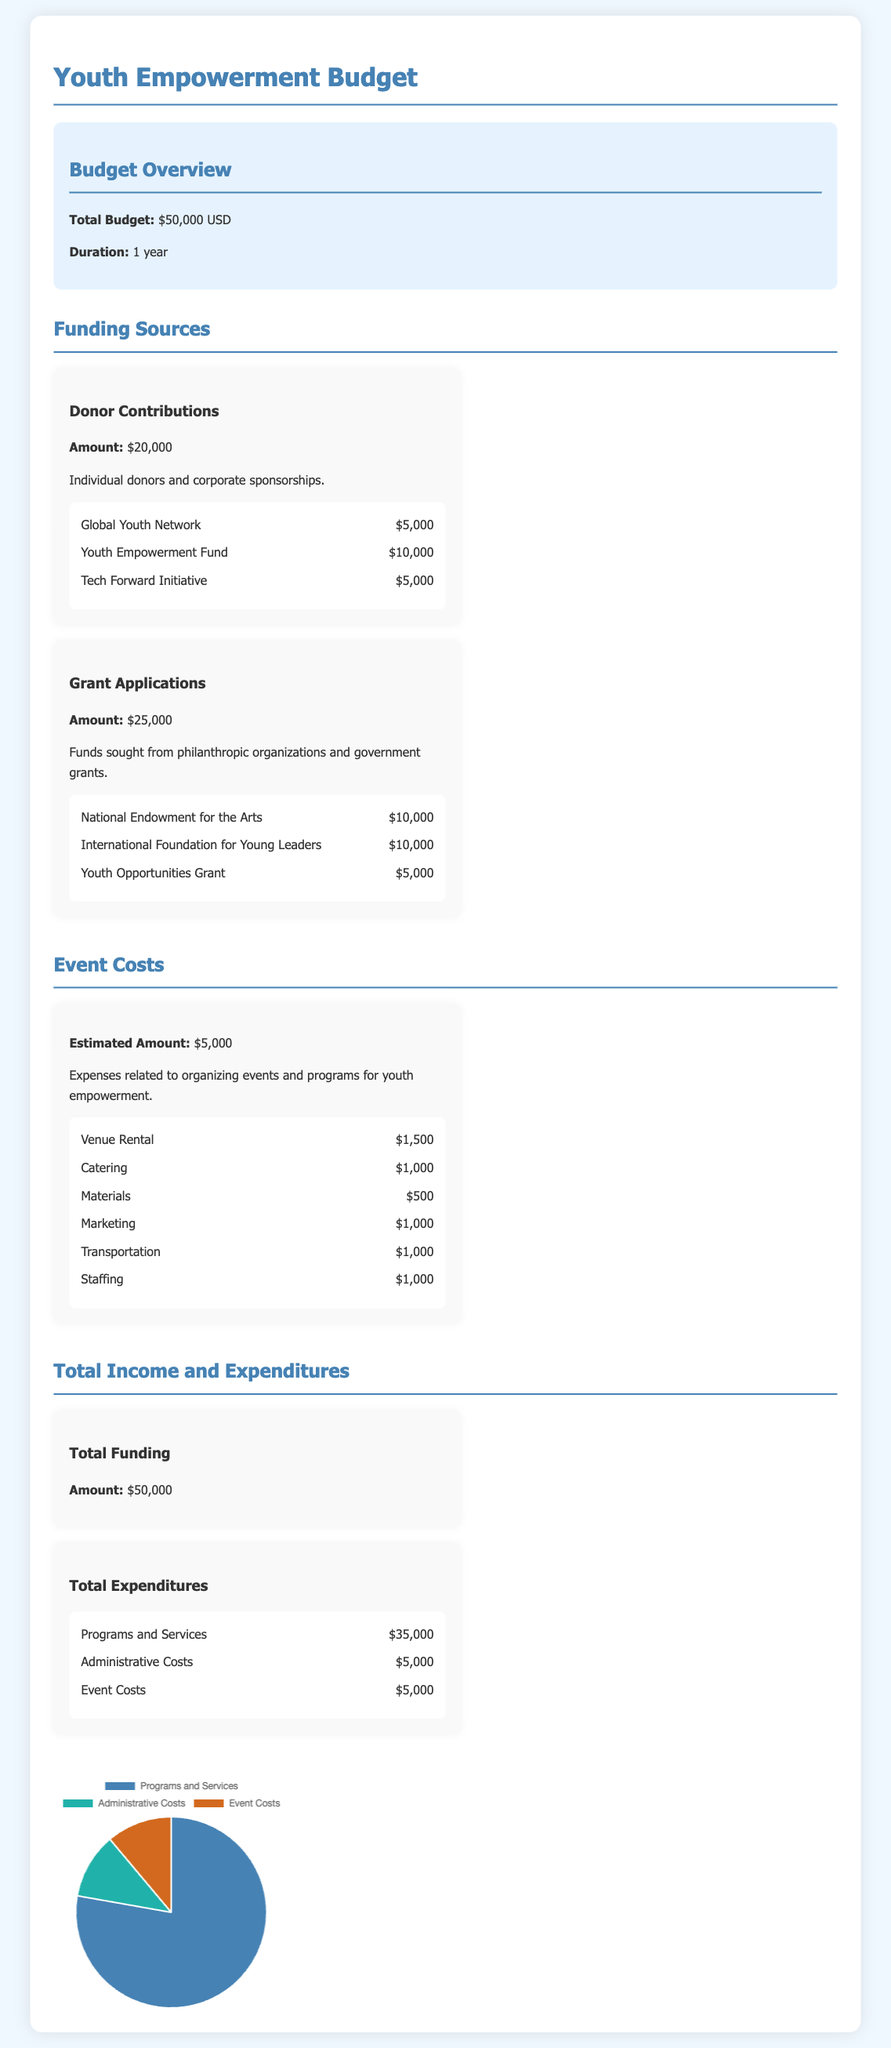what is the total budget? The total budget is stated clearly in the document as $50,000.
Answer: $50,000 how much is allocated for donor contributions? The document specifies that donor contributions amount to $20,000.
Answer: $20,000 what is the estimated amount for event costs? The estimated amount for event costs is listed as $5,000 in the document.
Answer: $5,000 how much funding is sought from grant applications? The document states that funding sought from grant applications is $25,000.
Answer: $25,000 what is the cost for venue rental? The breakdown shows that the cost for venue rental is $1,500.
Answer: $1,500 what are the total expenditures listed in the document? The total expenditures include Programs and Services, Administrative Costs, and Event Costs, which add up to $50,000.
Answer: $50,000 which organization contributes $10,000? The document indicates that the "International Foundation for Young Leaders" contributes $10,000.
Answer: International Foundation for Young Leaders how much is assigned to administrative costs? The document specifies that administrative costs total $5,000.
Answer: $5,000 what is the funding source for the Youth Opportunities Grant? The document lists the Youth Opportunities Grant under grant applications as a funding source.
Answer: Youth Opportunities Grant 